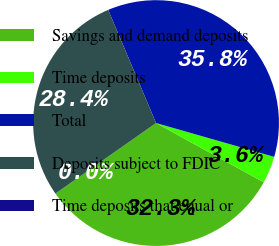Convert chart. <chart><loc_0><loc_0><loc_500><loc_500><pie_chart><fcel>Savings and demand deposits<fcel>Time deposits<fcel>Total<fcel>Deposits subject to FDIC<fcel>Time deposits that equal or<nl><fcel>32.26%<fcel>3.57%<fcel>35.81%<fcel>28.36%<fcel>0.01%<nl></chart> 